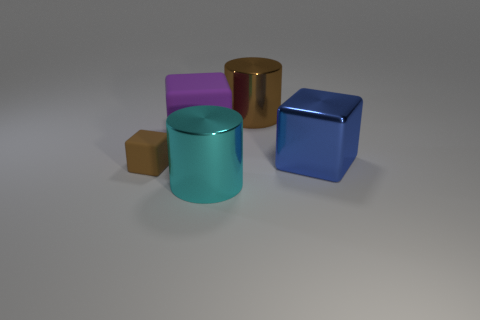What could be the possible uses for these objects in the real world? The objects could serve various purposes. The cubes, depending on their material, might be children's building blocks, weights for calibration, or decorative elements. The cylindrical objects could be containers, stands for objects, or components in some larger machinery or structure, again depending on their exact size and material. 